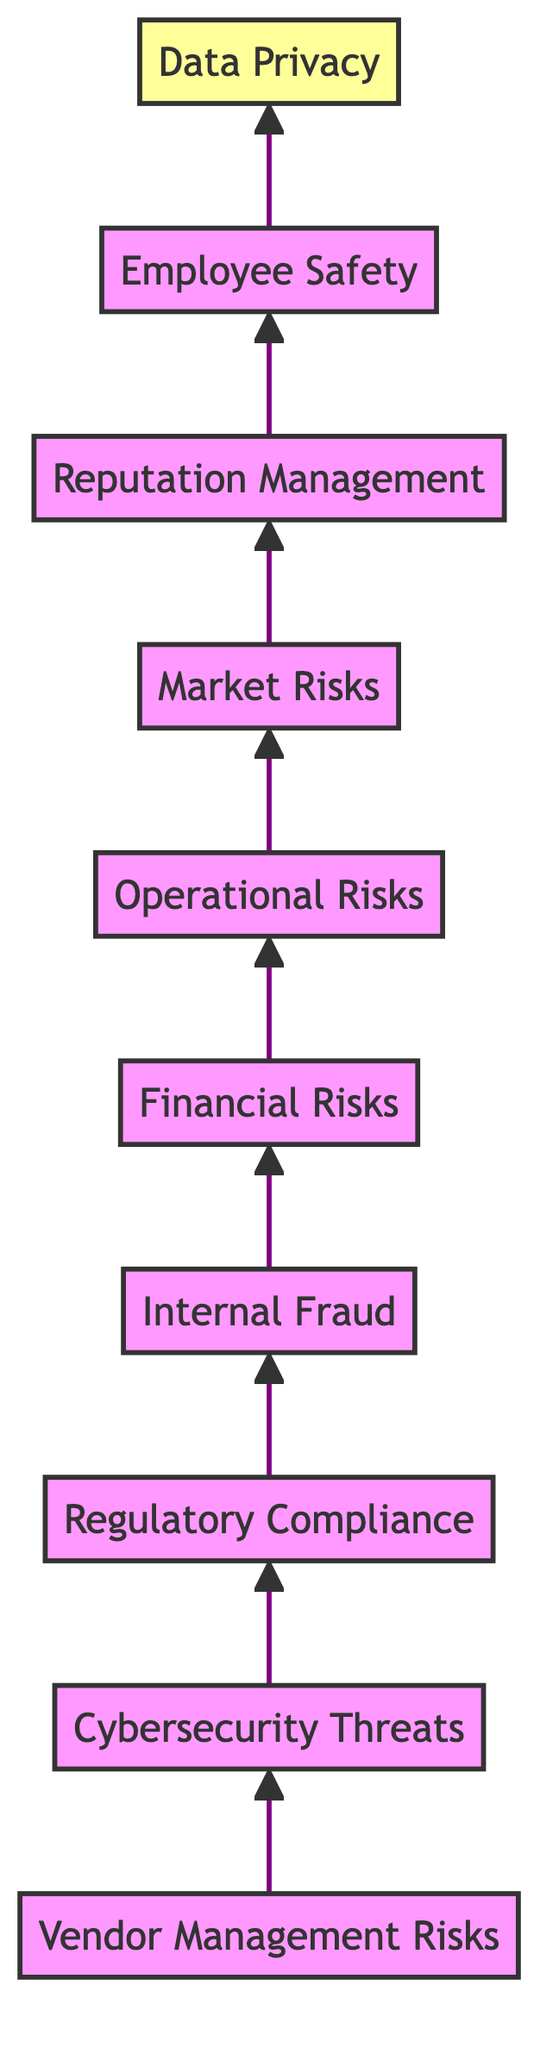What is the top node in the diagram? The top node is identified as "Data Privacy," which is the final node that draws all preceding elements together.
Answer: Data Privacy How many nodes are present in the flowchart? By counting each distinct element in the flowchart, we find that there are ten nodes listed, ranging from "Vendor Management Risks" to "Data Privacy."
Answer: Ten Which node comes directly after "Internal Fraud"? The node that follows "Internal Fraud" in the flow is "Financial Risks," marking a connection where internal security leads into financial considerations.
Answer: Financial Risks What is the relationship between "Cybersecurity Threats" and "Vendor Management Risks"? "Cybersecurity Threats" follows "Vendor Management Risks," indicating that assessing vendor risks is a precursor for tackling cybersecurity measures in the diagram.
Answer: Follows Which risk connects to "Reputation Management"? "Market Risks" is the node that comes directly before "Reputation Management," implying that how a company handles market fluctuations may affect its overall reputation.
Answer: Market Risks How many layers are there in the flowchart? The flowchart has a total of ten nodes arranged in a single vertical layer, with each node building upon the last from bottom to top.
Answer: One What type of risks are systematically addressed beginning from the bottom of the chart? The chart begins with "Vendor Management Risks" and systematically navigates through various risk categories up to "Data Privacy," indicating a structured recap of essential mitigative measures.
Answer: Vendor Management Risks Which element represents the ultimate priority in this risk mitigation strategy? The ultimate focus of the risk mitigation strategy is indicated by "Data Privacy," as it is the final destination of the flowchart sequence.
Answer: Data Privacy What risks are considered before addressing "Employee Safety"? Before reaching the concern of "Employee Safety," the flowchart outlines the nodes "Reputation Management" and "Market Risks," indicating a focus on external factors affecting employees' well-being.
Answer: Reputation Management and Market Risks 